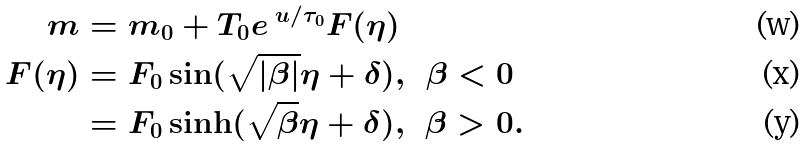<formula> <loc_0><loc_0><loc_500><loc_500>m & = m _ { 0 } + T _ { 0 } e ^ { \ u / \tau _ { 0 } } F ( \eta ) \\ F ( \eta ) & = F _ { 0 } \sin ( \sqrt { \left | \beta \right | } \eta + \delta ) , \text { \ } \beta < 0 \\ & = F _ { 0 } \sinh ( \sqrt { \beta } \eta + \delta ) , \text { \ } \beta > 0 .</formula> 